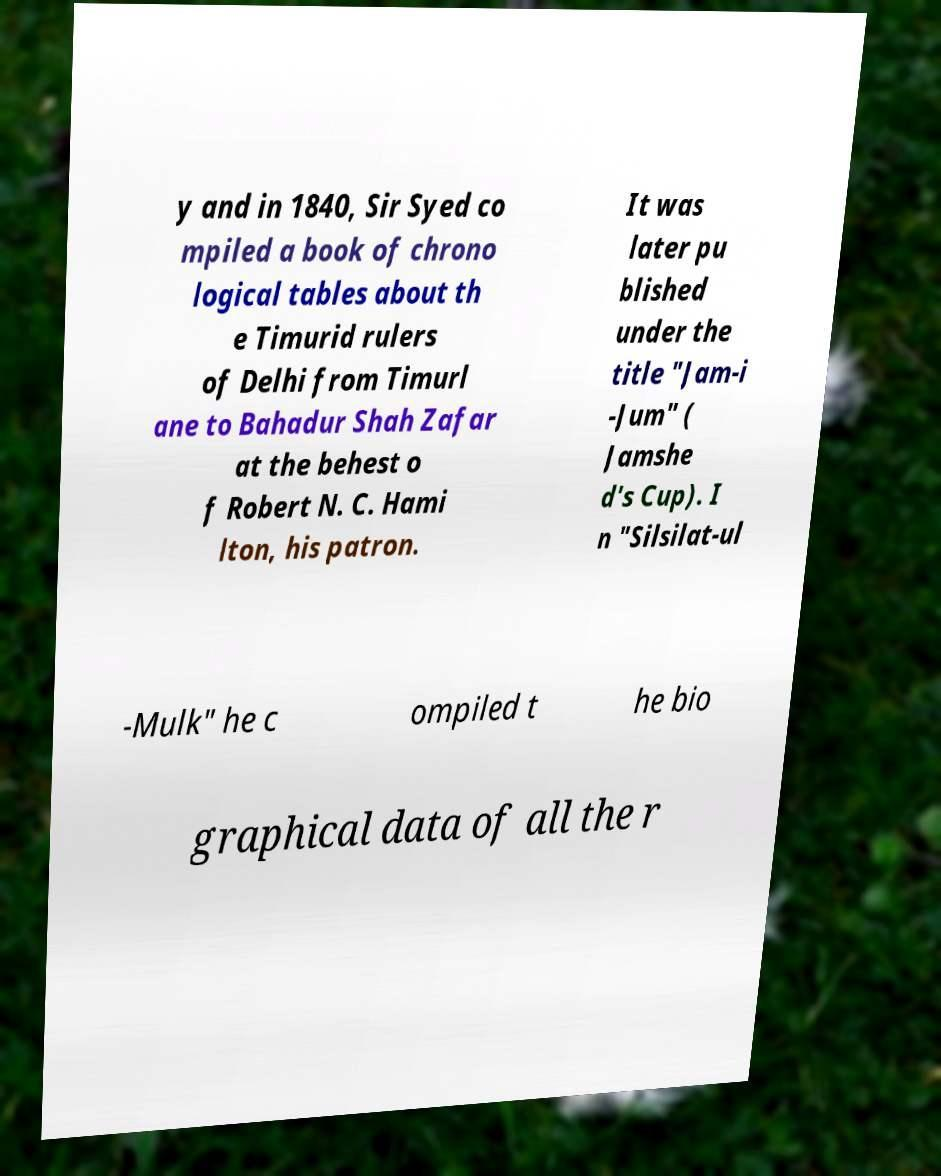For documentation purposes, I need the text within this image transcribed. Could you provide that? y and in 1840, Sir Syed co mpiled a book of chrono logical tables about th e Timurid rulers of Delhi from Timurl ane to Bahadur Shah Zafar at the behest o f Robert N. C. Hami lton, his patron. It was later pu blished under the title "Jam-i -Jum" ( Jamshe d's Cup). I n "Silsilat-ul -Mulk" he c ompiled t he bio graphical data of all the r 